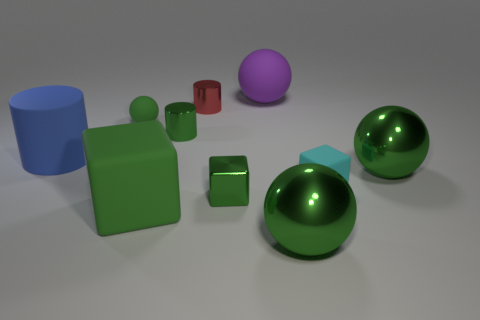How many green balls must be subtracted to get 1 green balls? 2 Subtract all red blocks. How many green balls are left? 3 Subtract 1 balls. How many balls are left? 3 Subtract all cyan cylinders. Subtract all blue balls. How many cylinders are left? 3 Subtract all spheres. How many objects are left? 6 Add 4 blue things. How many blue things are left? 5 Add 4 green things. How many green things exist? 10 Subtract 3 green balls. How many objects are left? 7 Subtract all big blue cylinders. Subtract all tiny things. How many objects are left? 4 